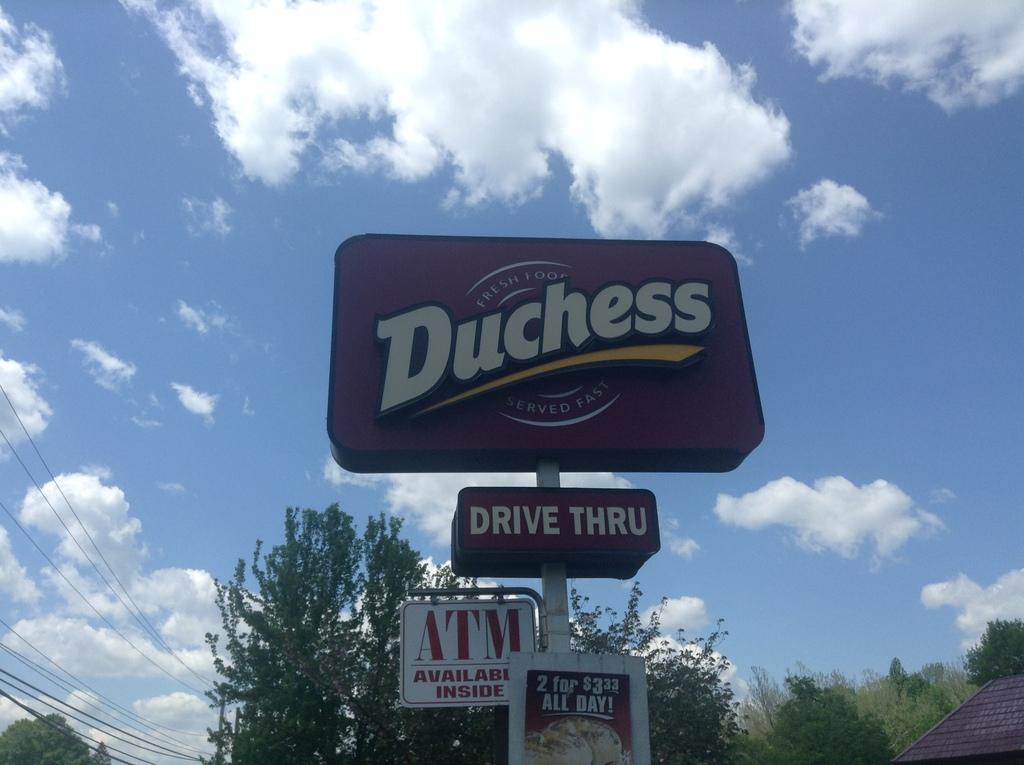<image>
Write a terse but informative summary of the picture. Outdoor Duchess billboard sign with saying Drive thru. 